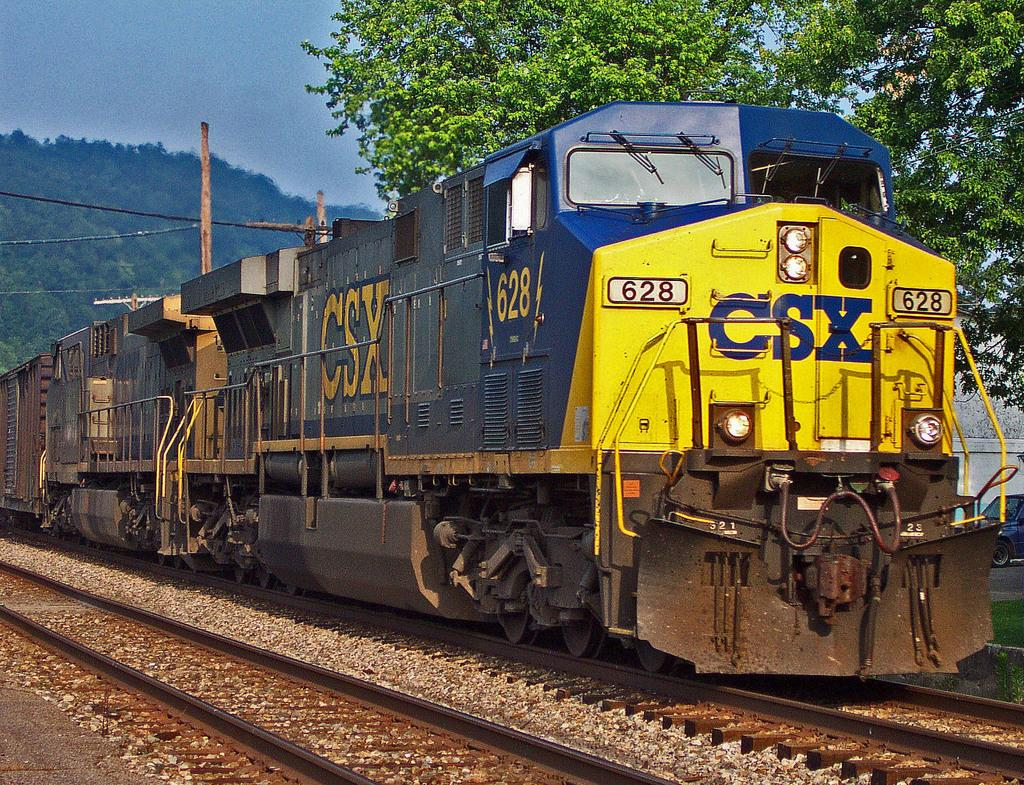What can be seen running parallel to each other in the image? There are two railway tracks in the image. What is traveling on the railway tracks? There is a yellow and blue color train on the tracks. What type of vegetation is present in the image? There are green color trees in the image. What color is the sky in the image? The sky is blue in the image. Can you hear the sound of a battle in the image? There is no sound or indication of a battle in the image; it features railway tracks, a train, trees, and a blue sky. What type of jelly can be seen on the train in the image? There is no jelly present on the train or anywhere in the image. 